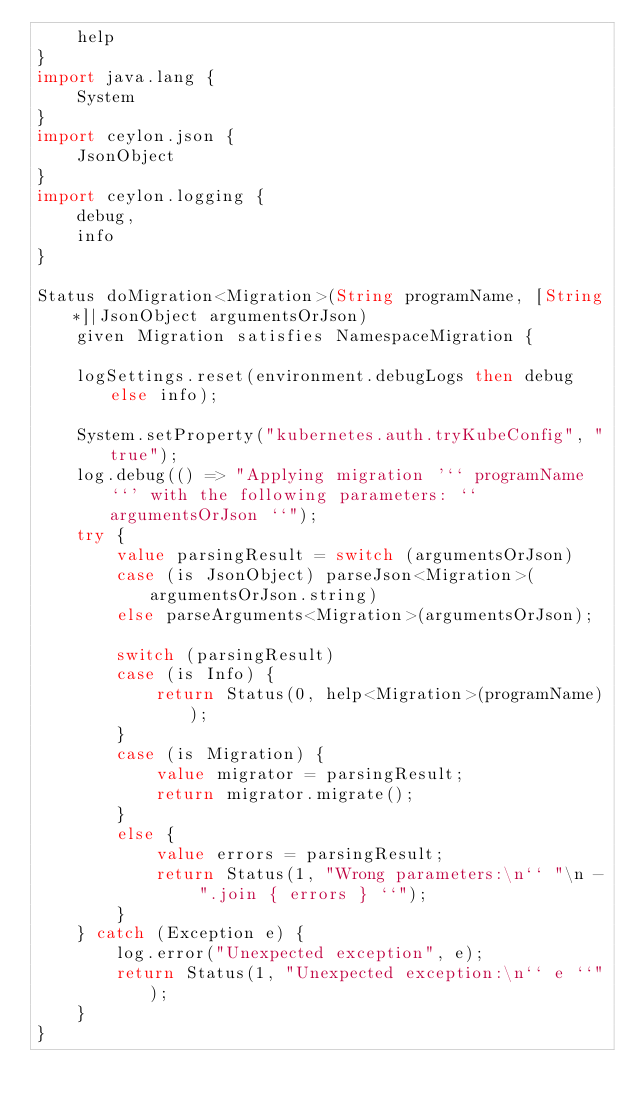<code> <loc_0><loc_0><loc_500><loc_500><_Ceylon_>    help
}
import java.lang {
    System
}
import ceylon.json {
    JsonObject
}
import ceylon.logging {
    debug,
    info
}

Status doMigration<Migration>(String programName, [String*]|JsonObject argumentsOrJson)
    given Migration satisfies NamespaceMigration {

    logSettings.reset(environment.debugLogs then debug else info);

    System.setProperty("kubernetes.auth.tryKubeConfig", "true");
    log.debug(() => "Applying migration '`` programName ``' with the following parameters: `` argumentsOrJson ``");
    try {
        value parsingResult = switch (argumentsOrJson)
        case (is JsonObject) parseJson<Migration>(argumentsOrJson.string)
        else parseArguments<Migration>(argumentsOrJson);

        switch (parsingResult)
        case (is Info) {
            return Status(0, help<Migration>(programName));
        }
        case (is Migration) {
            value migrator = parsingResult;
            return migrator.migrate();
        }
        else {
            value errors = parsingResult;
            return Status(1, "Wrong parameters:\n`` "\n - ".join { errors } ``");
        }
    } catch (Exception e) {
        log.error("Unexpected exception", e);
        return Status(1, "Unexpected exception:\n`` e ``");
    }
}
</code> 